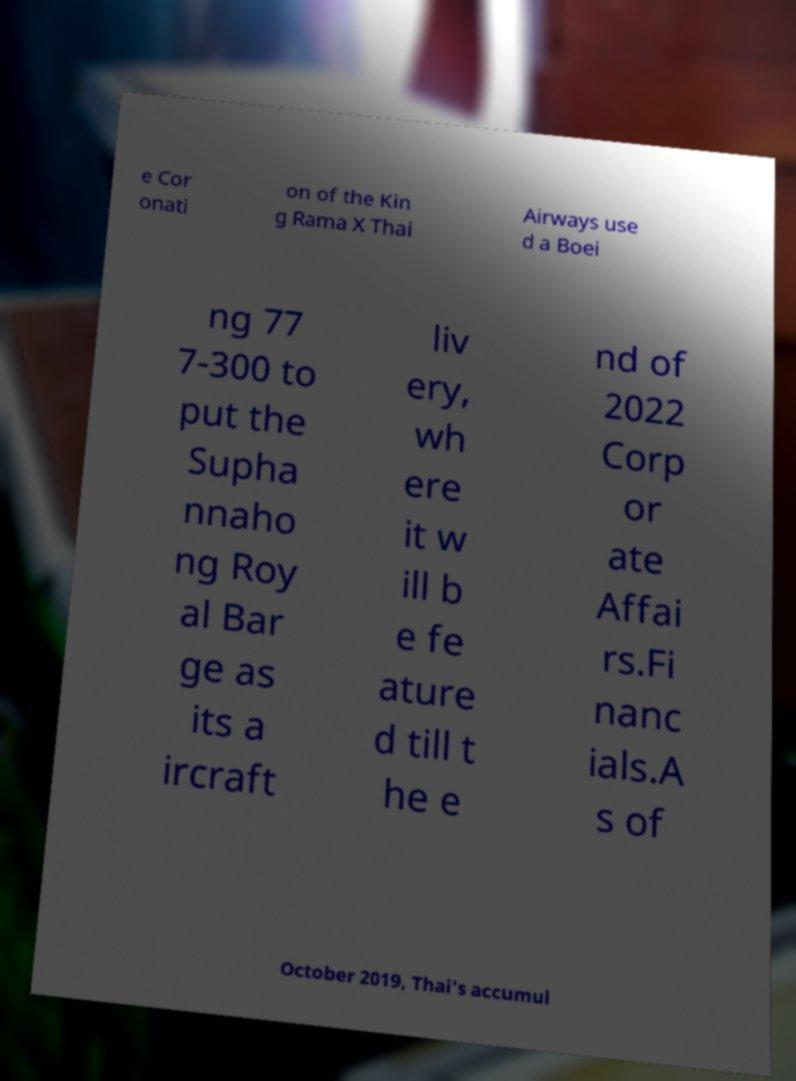For documentation purposes, I need the text within this image transcribed. Could you provide that? e Cor onati on of the Kin g Rama X Thai Airways use d a Boei ng 77 7-300 to put the Supha nnaho ng Roy al Bar ge as its a ircraft liv ery, wh ere it w ill b e fe ature d till t he e nd of 2022 Corp or ate Affai rs.Fi nanc ials.A s of October 2019, Thai's accumul 